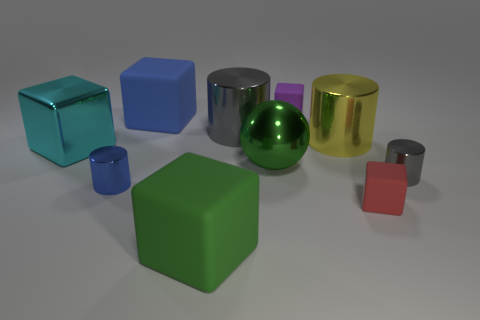Subtract all metal blocks. How many blocks are left? 4 Subtract all green cubes. How many cubes are left? 4 Subtract 1 cylinders. How many cylinders are left? 3 Subtract all purple blocks. How many blue cylinders are left? 1 Subtract all cylinders. How many objects are left? 6 Subtract all cyan cubes. Subtract all brown cylinders. How many cubes are left? 4 Subtract all shiny balls. Subtract all big green metal objects. How many objects are left? 8 Add 8 cyan metallic blocks. How many cyan metallic blocks are left? 9 Add 5 big yellow objects. How many big yellow objects exist? 6 Subtract 0 brown spheres. How many objects are left? 10 